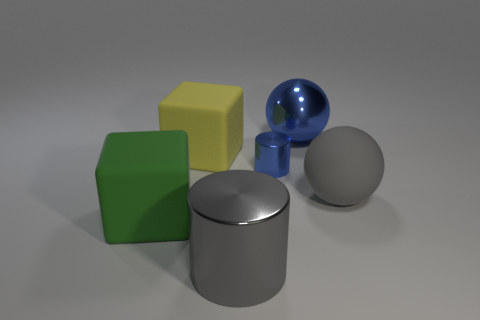There is a rubber cube that is behind the green matte thing; is it the same size as the large metallic sphere? It appears that the rubber cube, although partially obscured by the green object, is indeed comparable in size to the large metallic sphere. 